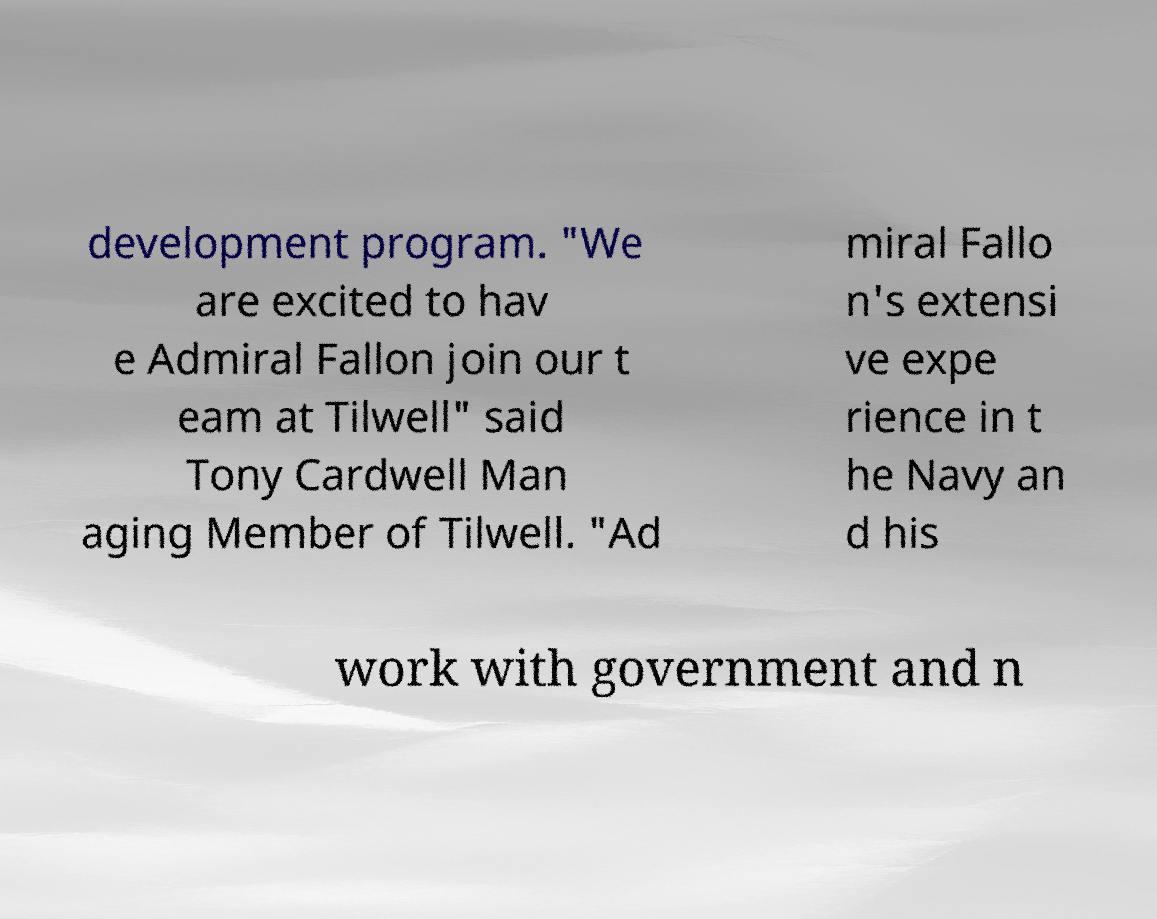What messages or text are displayed in this image? I need them in a readable, typed format. development program. "We are excited to hav e Admiral Fallon join our t eam at Tilwell" said Tony Cardwell Man aging Member of Tilwell. "Ad miral Fallo n's extensi ve expe rience in t he Navy an d his work with government and n 